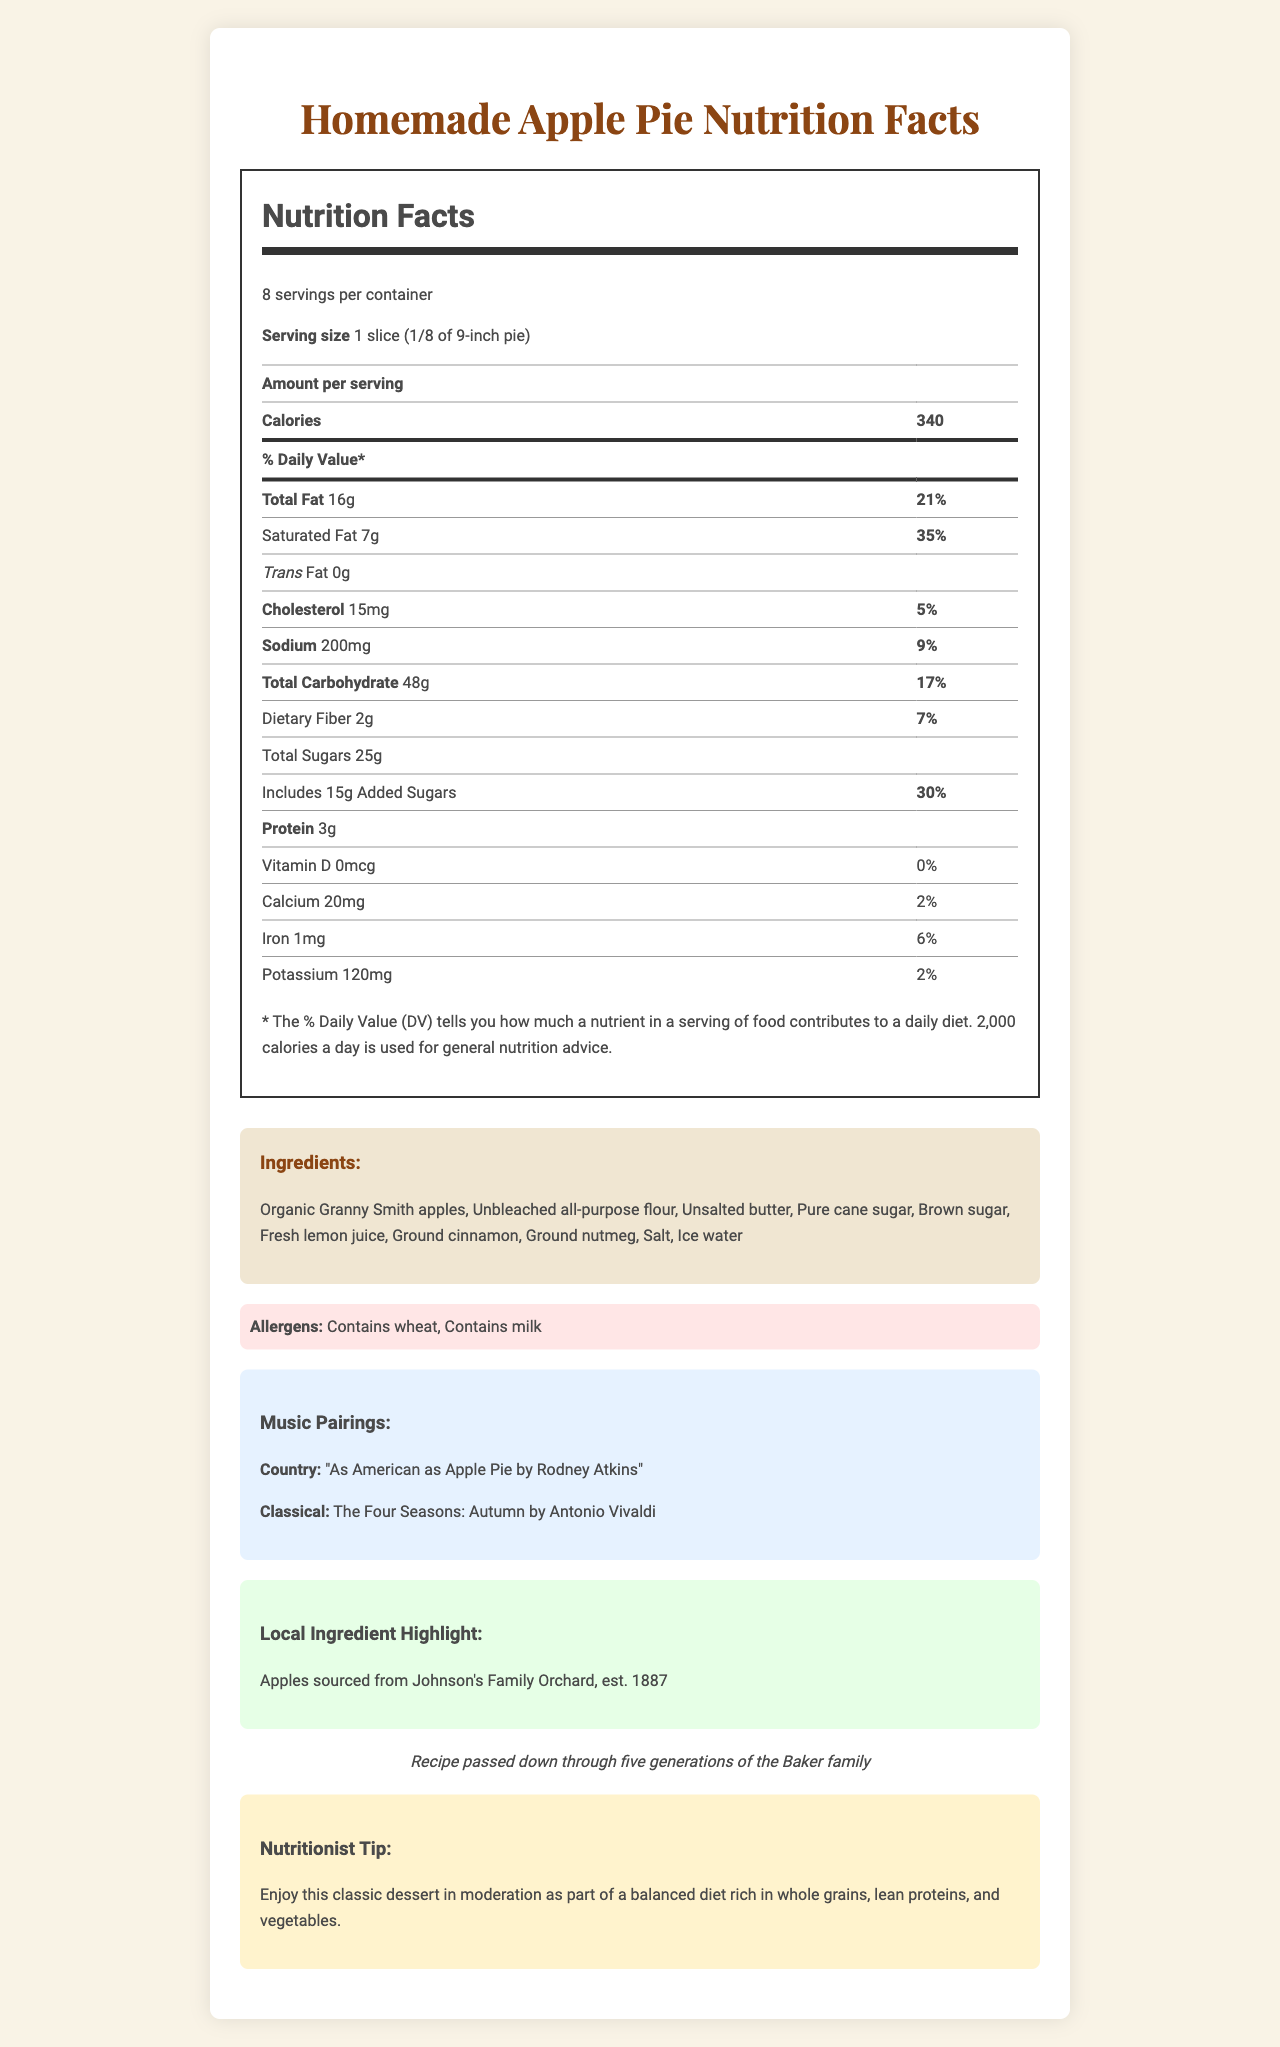What is the serving size for the apple pie? The label specifies that one serving size is one slice, which is 1/8 of a 9-inch pie.
Answer: 1 slice (1/8 of 9-inch pie) How many servings are in the entire pie? The label indicates that there are 8 servings per container.
Answer: 8 What is the calorie content per serving? The label shows that each serving has 340 calories.
Answer: 340 How much total fat is in one serving? The label states that one serving contains 16 grams of total fat.
Answer: 16g How much protein does one slice contain? The label details that each serving contains 3 grams of protein.
Answer: 3g How many grams of sugar are added sugars per serving? The label notes that there are 15 grams of added sugars per serving.
Answer: 15g What percentage of Vitamin D does one serving provide? The label specifies that one serving does not contribute to the daily value of Vitamin D.
Answer: 0% What allergens are present in the apple pie? The allergens listed in the document are wheat and milk.
Answer: Contains wheat, Contains milk Where are the apples in the pie sourced from? The document highlights that the apples are sourced from Johnson's Family Orchard, established in 1887.
Answer: Johnson's Family Orchard, est. 1887 Which family recipe is used for this apple pie? A. The Johnson family B. The Baker family C. The Smith family D. The Orchard family The document notes that the recipe has been passed down through five generations of the Baker family.
Answer: B Which classical music piece pairs well with this pie? I. Beethoven's Symphony No.9 II. Mozart's Eine kleine Nachtmusik III. Vivaldi's The Four Seasons: Autumn IV. Bach’s Brandenburg Concerto No.3 The label suggests pairing this apple pie with "The Four Seasons: Autumn" by Antonio Vivaldi.
Answer: III Is there any trans fat in the apple pie? The label indicates that the apple pie contains 0 grams of trans fat.
Answer: No Summarize the main idea of the document. The document focuses on delivering detailed nutritional information, an ingredient list, allergen warnings, additional context on the apple pie’s local and historical significance, and musical suggestions to enhance the eating experience.
Answer: The document provides the nutrition facts, ingredients, allergens, music pairings, local ingredient highlights, traditional preparation notes, and a nutritionist tip for a homemade apple pie, specifically one slice of an eighth of a 9-inch pie. It highlights the use of local apples from Johnson's Family Orchard and suggests musical pairings that align with the flavor and family tradition of the pie. How many calories come from fat per serving? The document does not provide the specific information needed to calculate the number of calories from fat per serving.
Answer: Cannot be determined 